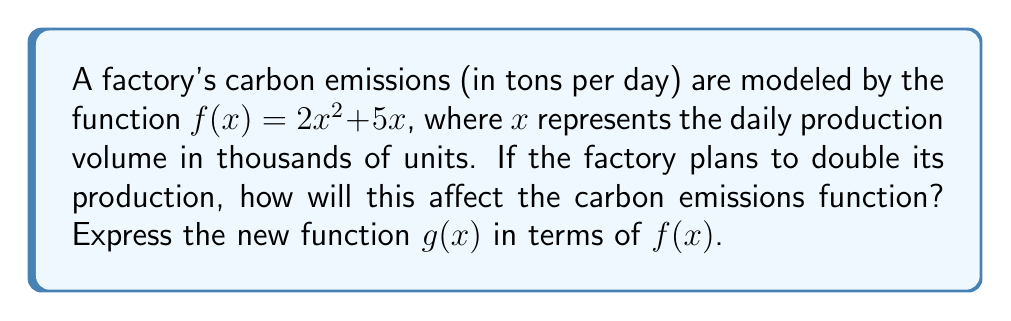Can you answer this question? 1. The original function is $f(x) = 2x^2 + 5x$.

2. Doubling production means replacing $x$ with $2x$ in the original function.

3. Let's substitute $2x$ for $x$ in $f(x)$:
   $g(x) = 2(2x)^2 + 5(2x)$

4. Simplify the squared term:
   $g(x) = 2(4x^2) + 5(2x)$

5. Distribute the 2:
   $g(x) = 8x^2 + 10x$

6. Now, let's compare this to the original function $f(x) = 2x^2 + 5x$:
   We can see that the coefficient of $x^2$ has been multiplied by 4, and the coefficient of $x$ has been multiplied by 2.

7. This can be expressed as:
   $g(x) = 4(2x^2) + 2(5x)$

8. Which simplifies to:
   $g(x) = 4f(\frac{1}{2}x)$

This means the new function $g(x)$ is a vertical stretch by a factor of 4 and a horizontal compression by a factor of $\frac{1}{2}$ of the original function $f(x)$.
Answer: $g(x) = 4f(\frac{1}{2}x)$ 